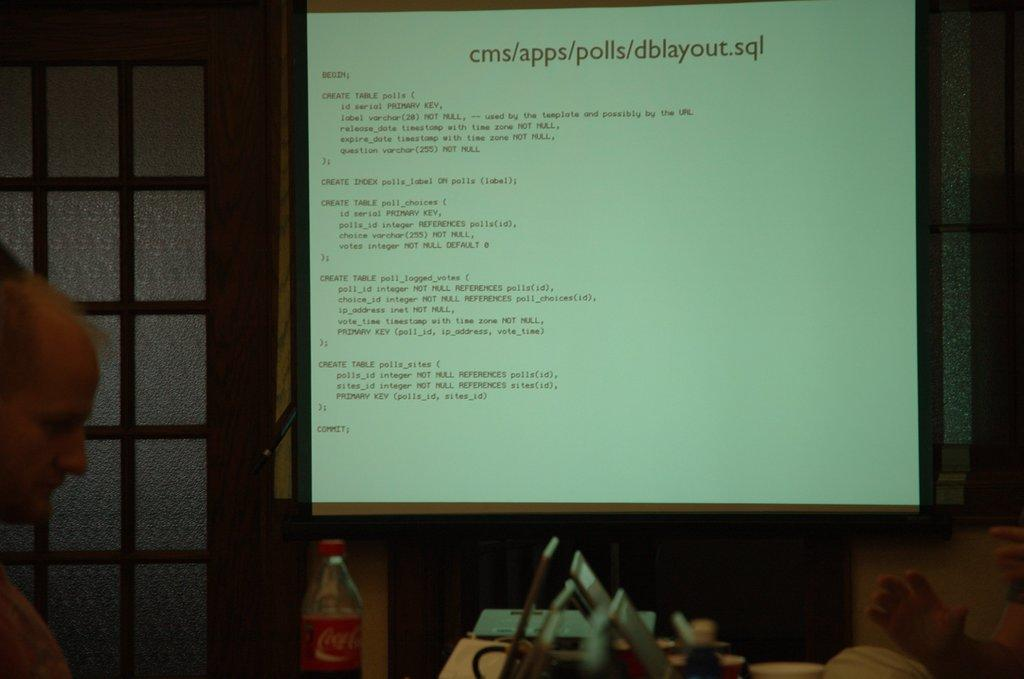<image>
Relay a brief, clear account of the picture shown. The source code for dblayout.sql being projected onto a large screen. 